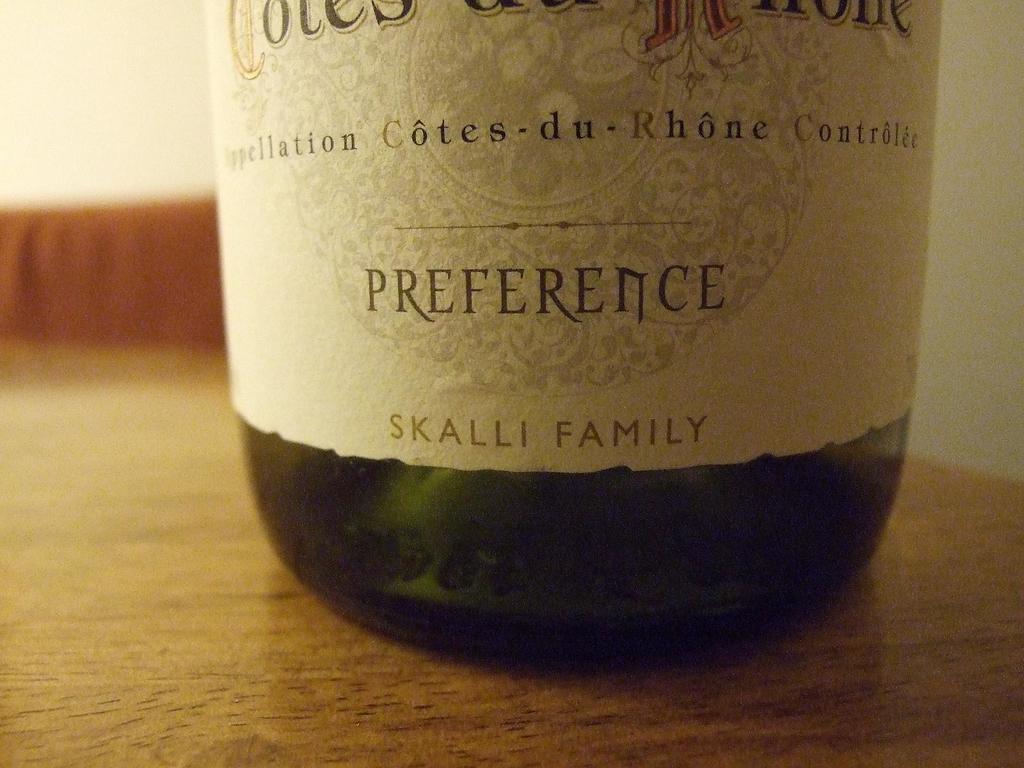What is the name of the of the adult beverage?
Provide a succinct answer. Preference. 